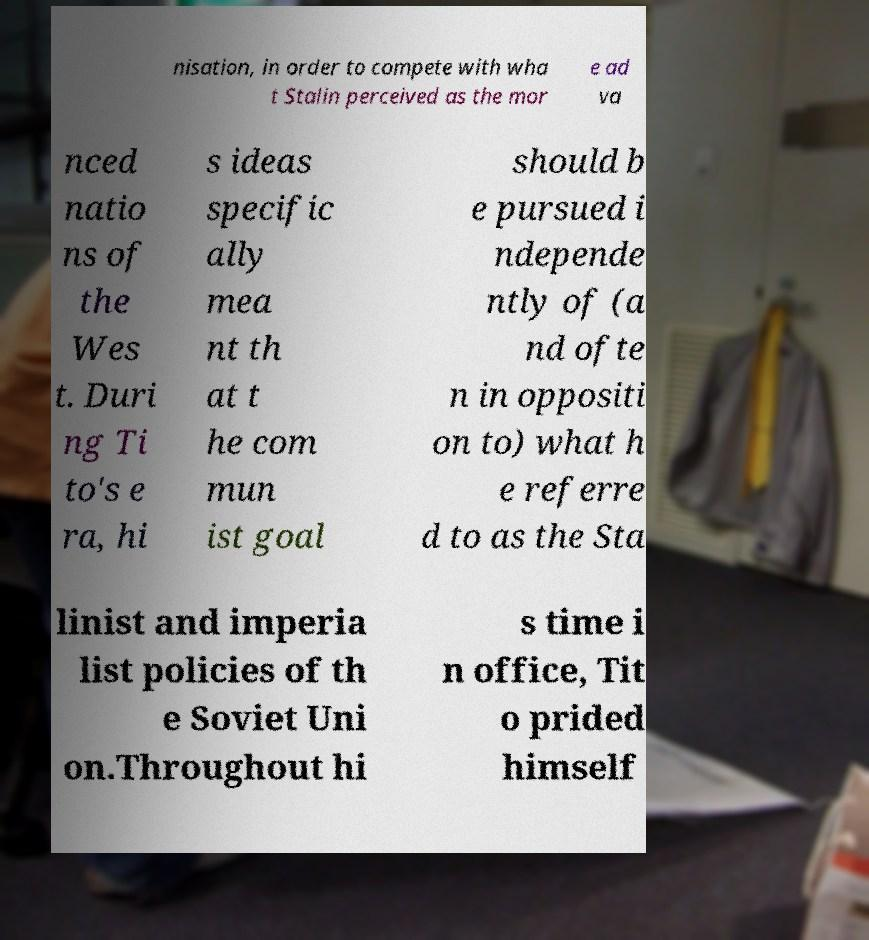Can you read and provide the text displayed in the image?This photo seems to have some interesting text. Can you extract and type it out for me? nisation, in order to compete with wha t Stalin perceived as the mor e ad va nced natio ns of the Wes t. Duri ng Ti to's e ra, hi s ideas specific ally mea nt th at t he com mun ist goal should b e pursued i ndepende ntly of (a nd ofte n in oppositi on to) what h e referre d to as the Sta linist and imperia list policies of th e Soviet Uni on.Throughout hi s time i n office, Tit o prided himself 